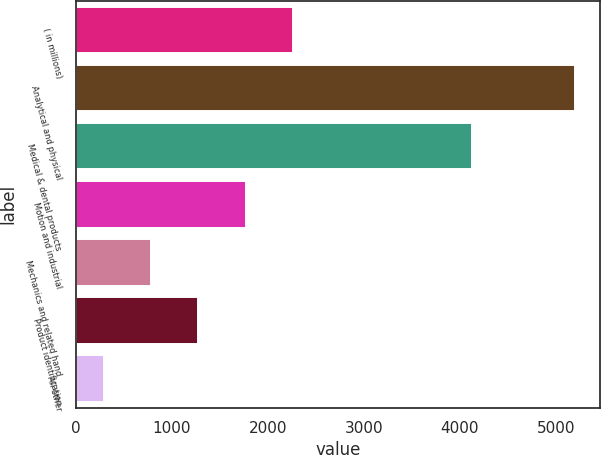Convert chart. <chart><loc_0><loc_0><loc_500><loc_500><bar_chart><fcel>( in millions)<fcel>Analytical and physical<fcel>Medical & dental products<fcel>Motion and industrial<fcel>Mechanics and related hand<fcel>Product identification<fcel>All other<nl><fcel>2258.86<fcel>5206<fcel>4122.9<fcel>1767.67<fcel>785.29<fcel>1276.48<fcel>294.1<nl></chart> 